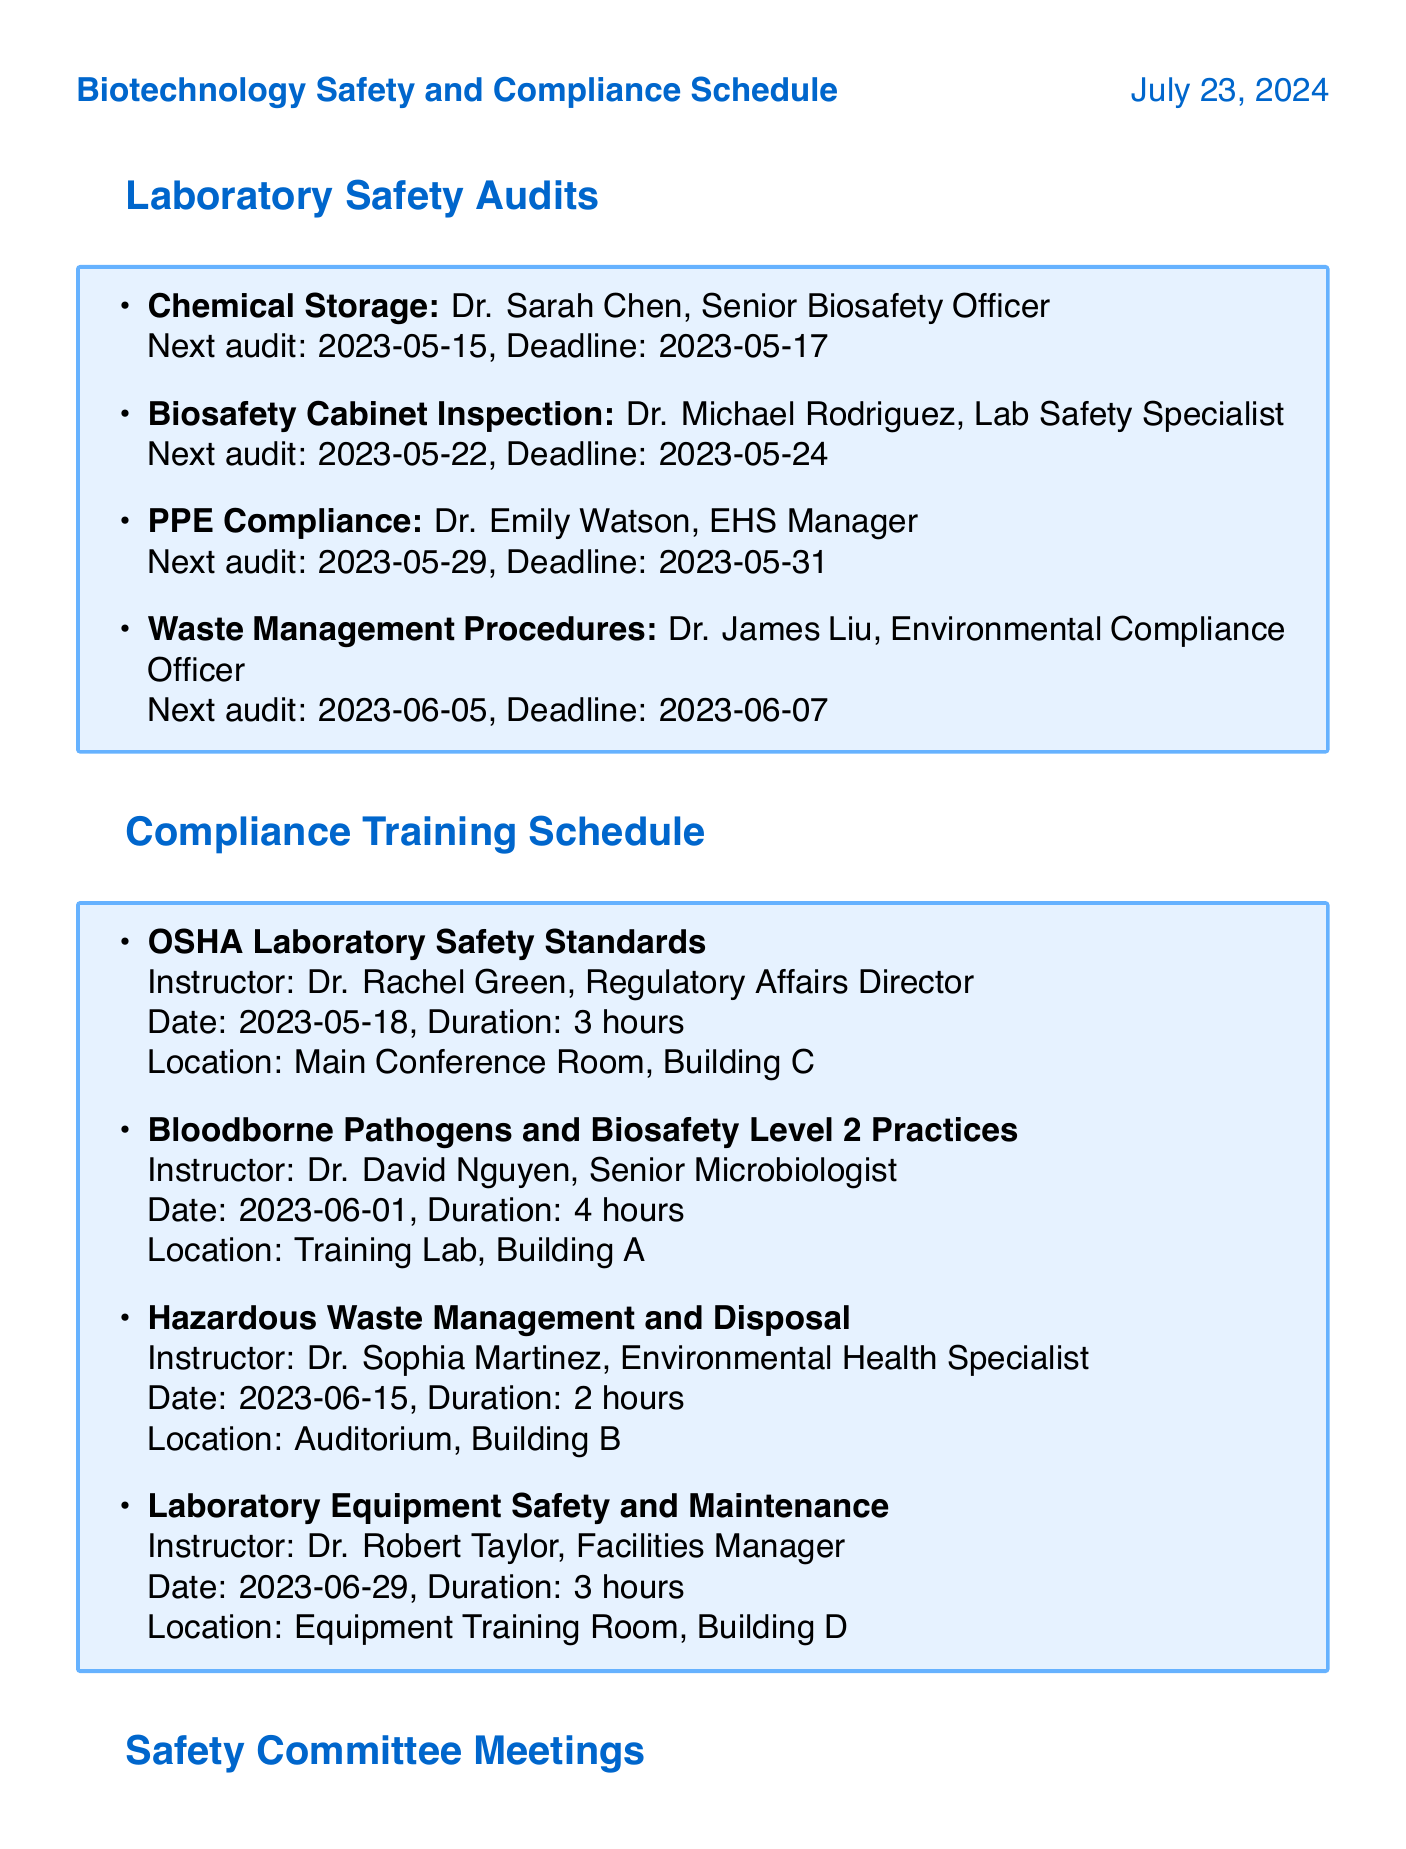what is the next audit date for Chemical Storage? The next audit date for Chemical Storage is listed in the document under laboratory safety audits.
Answer: 2023-05-15 who is assigned to conduct the Biosafety Cabinet Inspection? The document specifies the assigned auditor for the Biosafety Cabinet Inspection under laboratory safety audits.
Answer: Dr. Michael Rodriguez, Lab Safety Specialist when is the training on OSHA Laboratory Safety Standards scheduled? The document contains the date of the training for OSHA Laboratory Safety Standards under the compliance training schedule.
Answer: 2023-05-18 what is the duration of the training on Bloodborne Pathogens? The duration of this training is mentioned under the compliance training schedule.
Answer: 4 hours which laboratory safety audit is scheduled for June 5th, 2023? The document lists the audits scheduled on that date within the laboratory safety audits section.
Answer: Waste Management Procedures what is the target audience for the Hazardous Waste Management and Disposal training? The target audience is specified for each training session in the compliance training schedule.
Answer: All laboratory staff and research assistants who chairs the Monthly Safety Review meeting? The chairperson of this meeting is mentioned clearly in the safety committee meetings section of the document.
Answer: Dr. Elizabeth Adams, Chief Scientific Officer when is the completion deadline for the audit on PPE Compliance? The deadline for completing the PPE Compliance audit is detailed under the laboratory safety audits.
Answer: 2023-05-31 what initiative is led by Dr. Maria Santos? The document lists several safety improvement initiatives along with their project leads.
Answer: Implementation of Electronic Laboratory Notebook System 